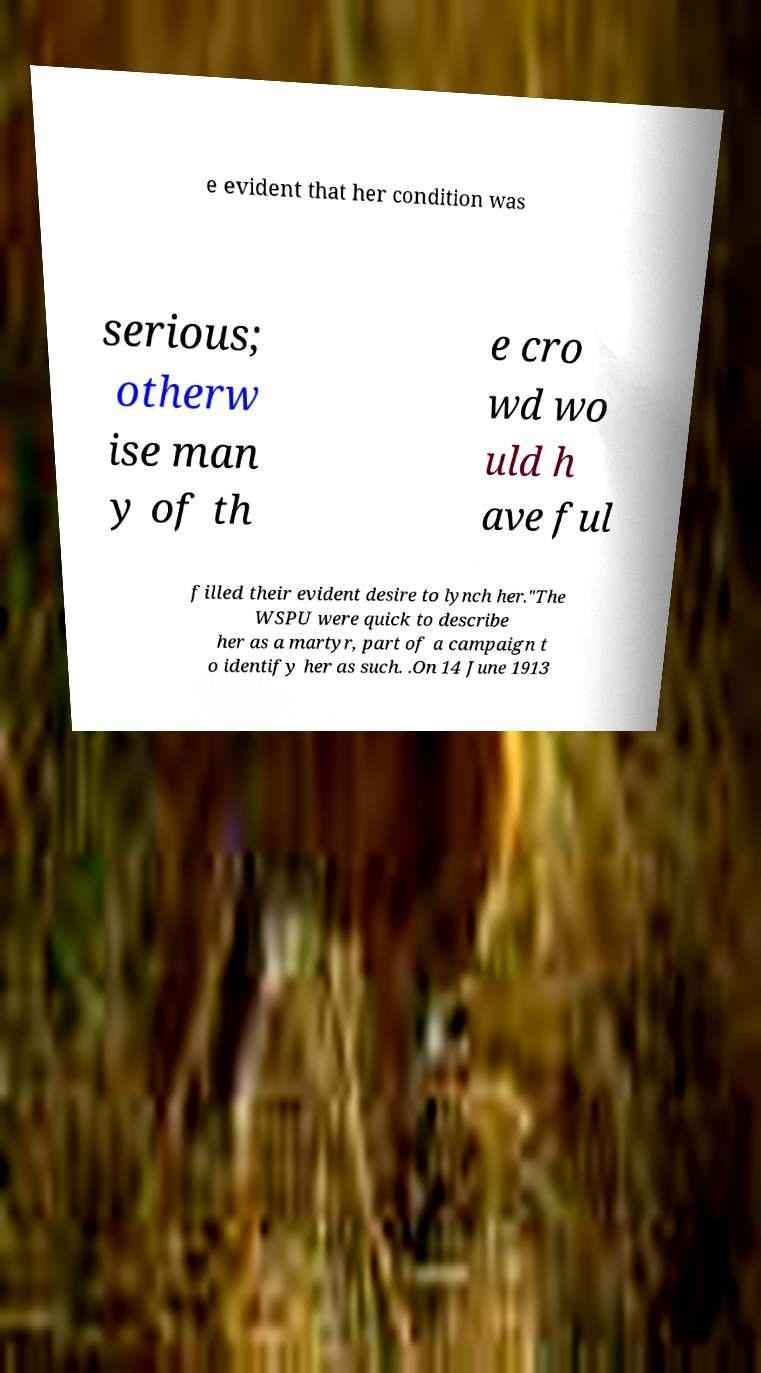Please identify and transcribe the text found in this image. e evident that her condition was serious; otherw ise man y of th e cro wd wo uld h ave ful filled their evident desire to lynch her."The WSPU were quick to describe her as a martyr, part of a campaign t o identify her as such. .On 14 June 1913 